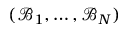Convert formula to latex. <formula><loc_0><loc_0><loc_500><loc_500>( \mathcal { B } _ { 1 } , \dots , \mathcal { B } _ { N } )</formula> 